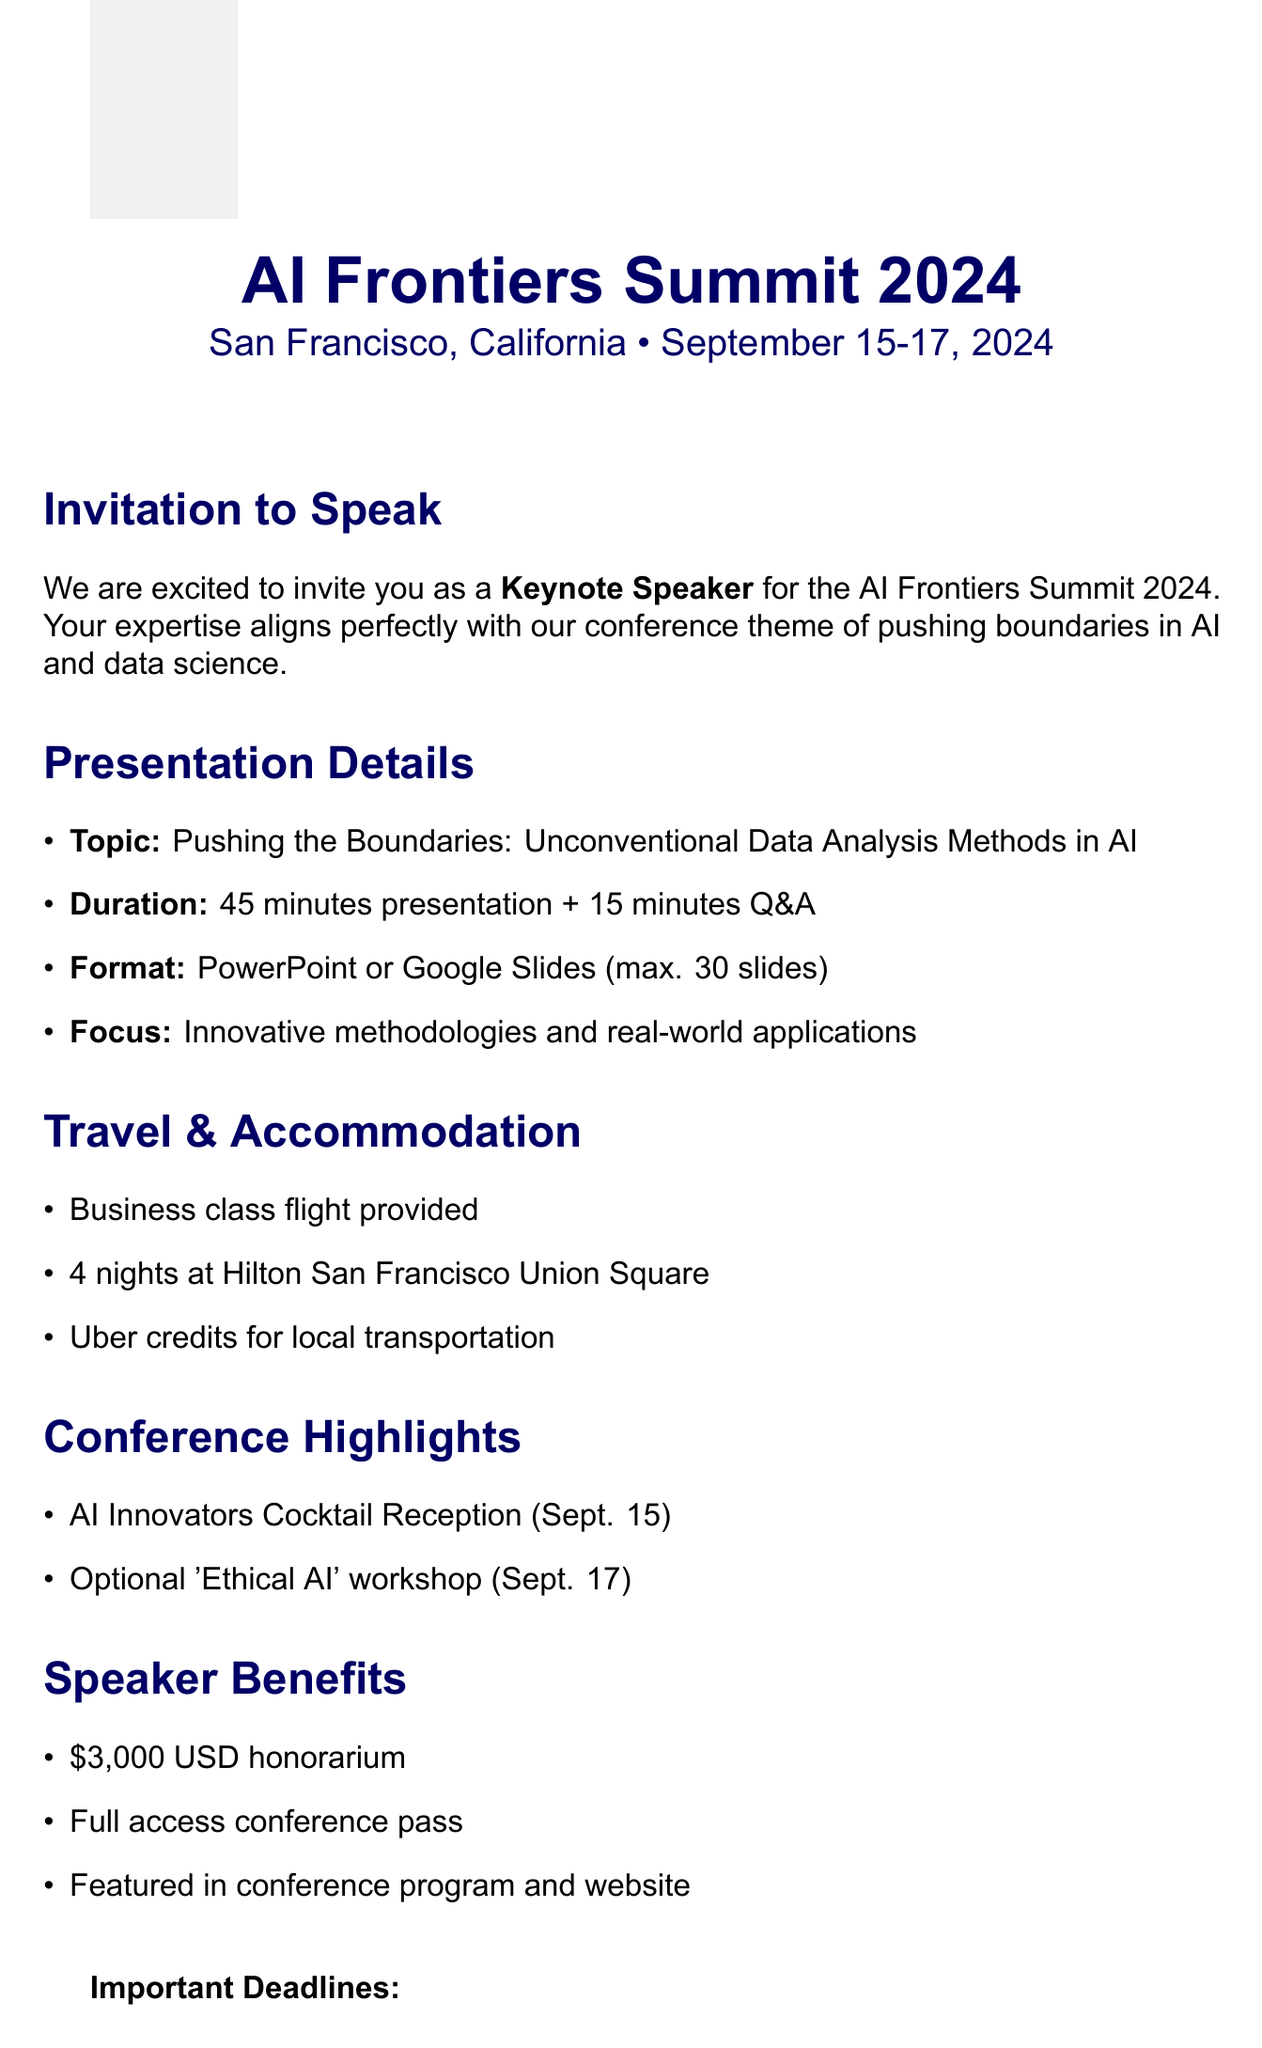What are the conference dates? The conference dates are specified in the document as September 15-17, 2024.
Answer: September 15-17, 2024 Who is the keynote speaker? The document invites the recipient as a Keynote Speaker, so the answer pertains to them.
Answer: Keynote Speaker What is the honorarium for the speaker? The honorarium is a specified benefit mentioned in the document, listed as $3,000 USD.
Answer: $3,000 USD What is the maximum number of slides allowed? The document outlines the presentation guidelines, which state the maximum slide count is 30.
Answer: Maximum 30 slides What type of transportation is provided? The travel arrangements include details about local transportation, specifically noting Uber credits are provided.
Answer: Uber credits What is emphasized in the content focus? The content focus of the presentation emphasizes innovative methodologies and real-world applications as mentioned in the guidelines.
Answer: Innovative methodologies and real-world applications When is the materials submission deadline? The document lists the deadline for submitting presentation slides as August 31, 2024.
Answer: August 31, 2024 What workshop can speakers optionally participate in? The conference highlights mention an optional participation workshop titled 'Ethical AI.'
Answer: 'Ethical AI' workshop What city is the conference located in? The location of the conference is clearly stated as San Francisco, California.
Answer: San Francisco, California 